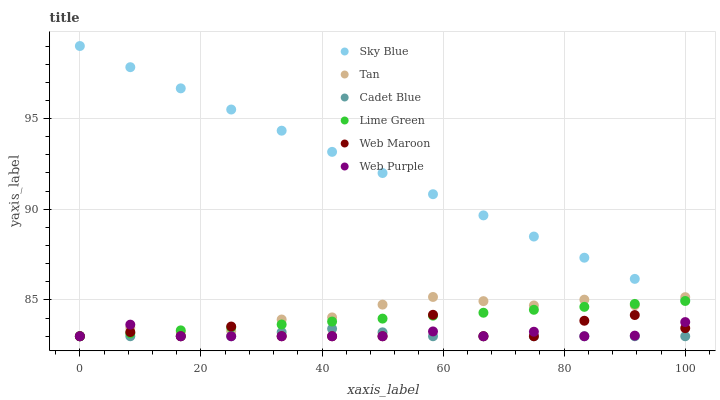Does Cadet Blue have the minimum area under the curve?
Answer yes or no. Yes. Does Sky Blue have the maximum area under the curve?
Answer yes or no. Yes. Does Web Maroon have the minimum area under the curve?
Answer yes or no. No. Does Web Maroon have the maximum area under the curve?
Answer yes or no. No. Is Lime Green the smoothest?
Answer yes or no. Yes. Is Web Maroon the roughest?
Answer yes or no. Yes. Is Web Purple the smoothest?
Answer yes or no. No. Is Web Purple the roughest?
Answer yes or no. No. Does Cadet Blue have the lowest value?
Answer yes or no. Yes. Does Sky Blue have the lowest value?
Answer yes or no. No. Does Sky Blue have the highest value?
Answer yes or no. Yes. Does Web Maroon have the highest value?
Answer yes or no. No. Is Lime Green less than Sky Blue?
Answer yes or no. Yes. Is Sky Blue greater than Cadet Blue?
Answer yes or no. Yes. Does Web Maroon intersect Cadet Blue?
Answer yes or no. Yes. Is Web Maroon less than Cadet Blue?
Answer yes or no. No. Is Web Maroon greater than Cadet Blue?
Answer yes or no. No. Does Lime Green intersect Sky Blue?
Answer yes or no. No. 